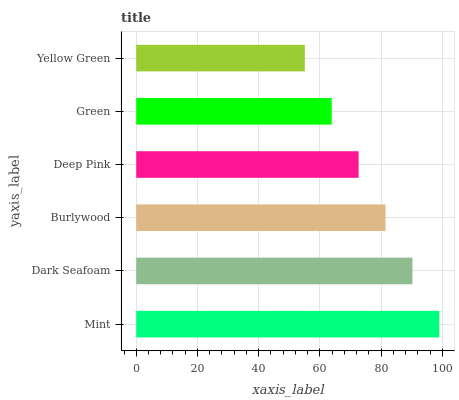Is Yellow Green the minimum?
Answer yes or no. Yes. Is Mint the maximum?
Answer yes or no. Yes. Is Dark Seafoam the minimum?
Answer yes or no. No. Is Dark Seafoam the maximum?
Answer yes or no. No. Is Mint greater than Dark Seafoam?
Answer yes or no. Yes. Is Dark Seafoam less than Mint?
Answer yes or no. Yes. Is Dark Seafoam greater than Mint?
Answer yes or no. No. Is Mint less than Dark Seafoam?
Answer yes or no. No. Is Burlywood the high median?
Answer yes or no. Yes. Is Deep Pink the low median?
Answer yes or no. Yes. Is Mint the high median?
Answer yes or no. No. Is Dark Seafoam the low median?
Answer yes or no. No. 